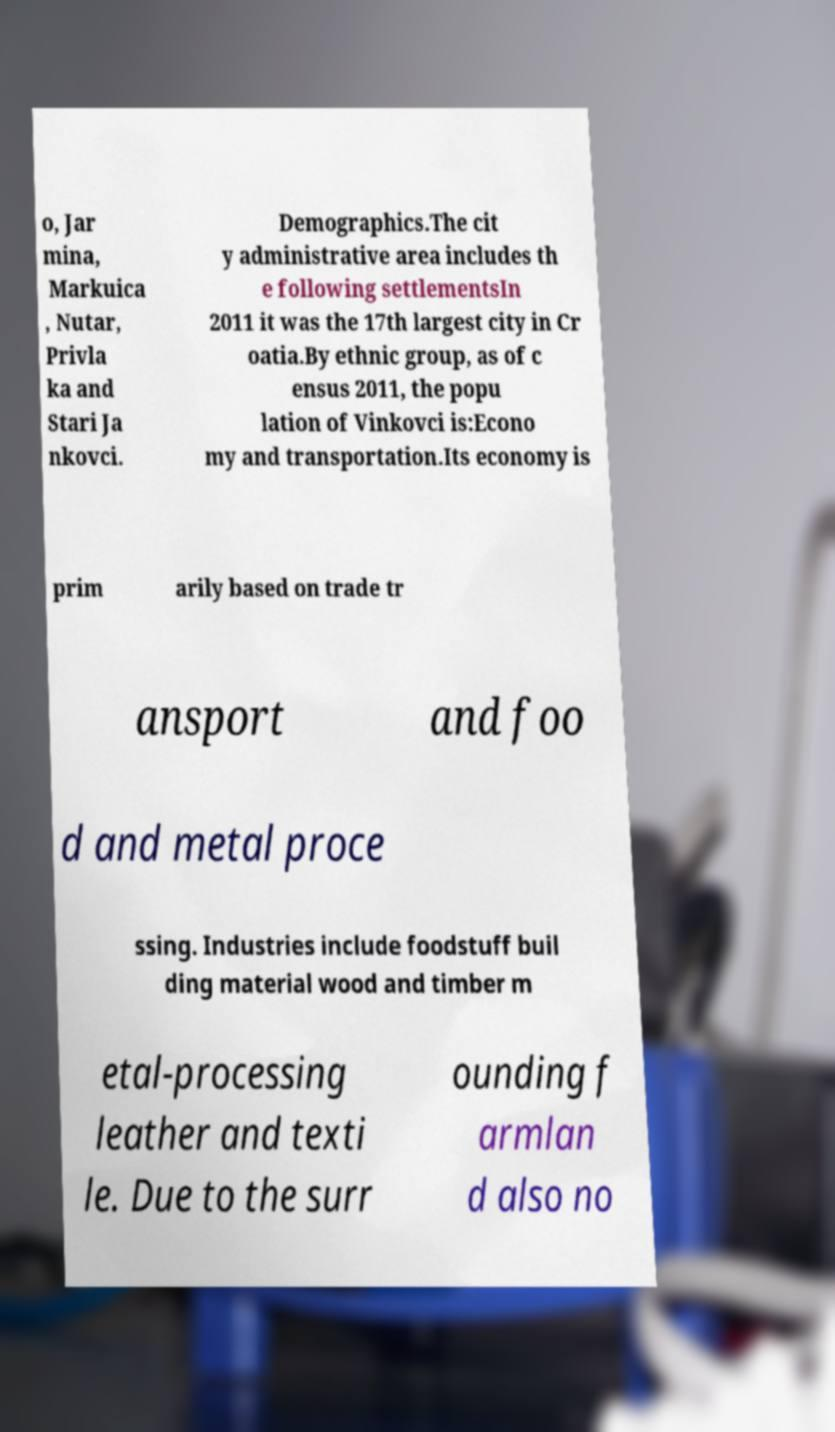There's text embedded in this image that I need extracted. Can you transcribe it verbatim? o, Jar mina, Markuica , Nutar, Privla ka and Stari Ja nkovci. Demographics.The cit y administrative area includes th e following settlementsIn 2011 it was the 17th largest city in Cr oatia.By ethnic group, as of c ensus 2011, the popu lation of Vinkovci is:Econo my and transportation.Its economy is prim arily based on trade tr ansport and foo d and metal proce ssing. Industries include foodstuff buil ding material wood and timber m etal-processing leather and texti le. Due to the surr ounding f armlan d also no 